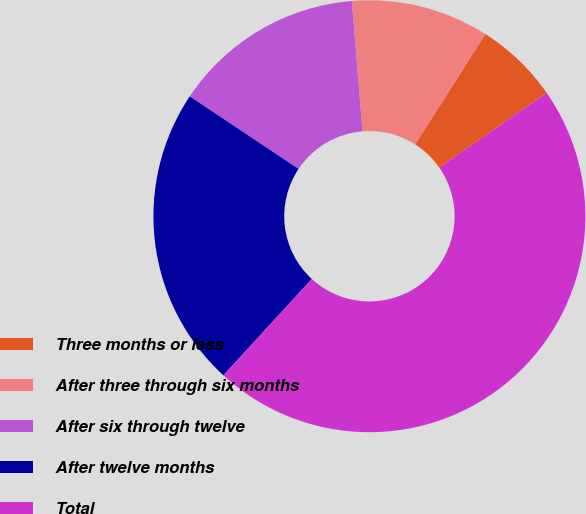Convert chart to OTSL. <chart><loc_0><loc_0><loc_500><loc_500><pie_chart><fcel>Three months or less<fcel>After three through six months<fcel>After six through twelve<fcel>After twelve months<fcel>Total<nl><fcel>6.3%<fcel>10.32%<fcel>14.34%<fcel>22.55%<fcel>46.5%<nl></chart> 